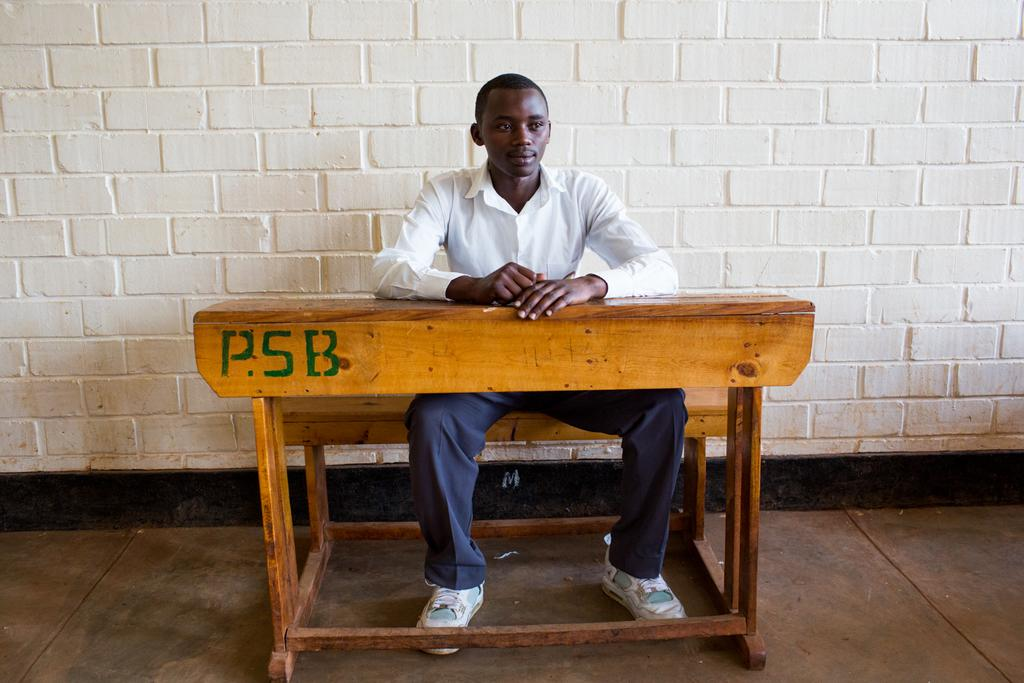What is located in the middle of the image? There is a bench in the middle of the image. What is the man in the image doing? A man is sitting on the bench. What is visible behind the man? There is a wall behind the man. What type of tin can be seen in the image? There is no tin present in the image. Is the man in the image in jail? There is no indication in the image that the man is in jail. 